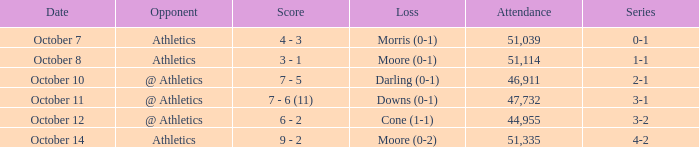When was the game with the loss of Moore (0-1)? October 8. 